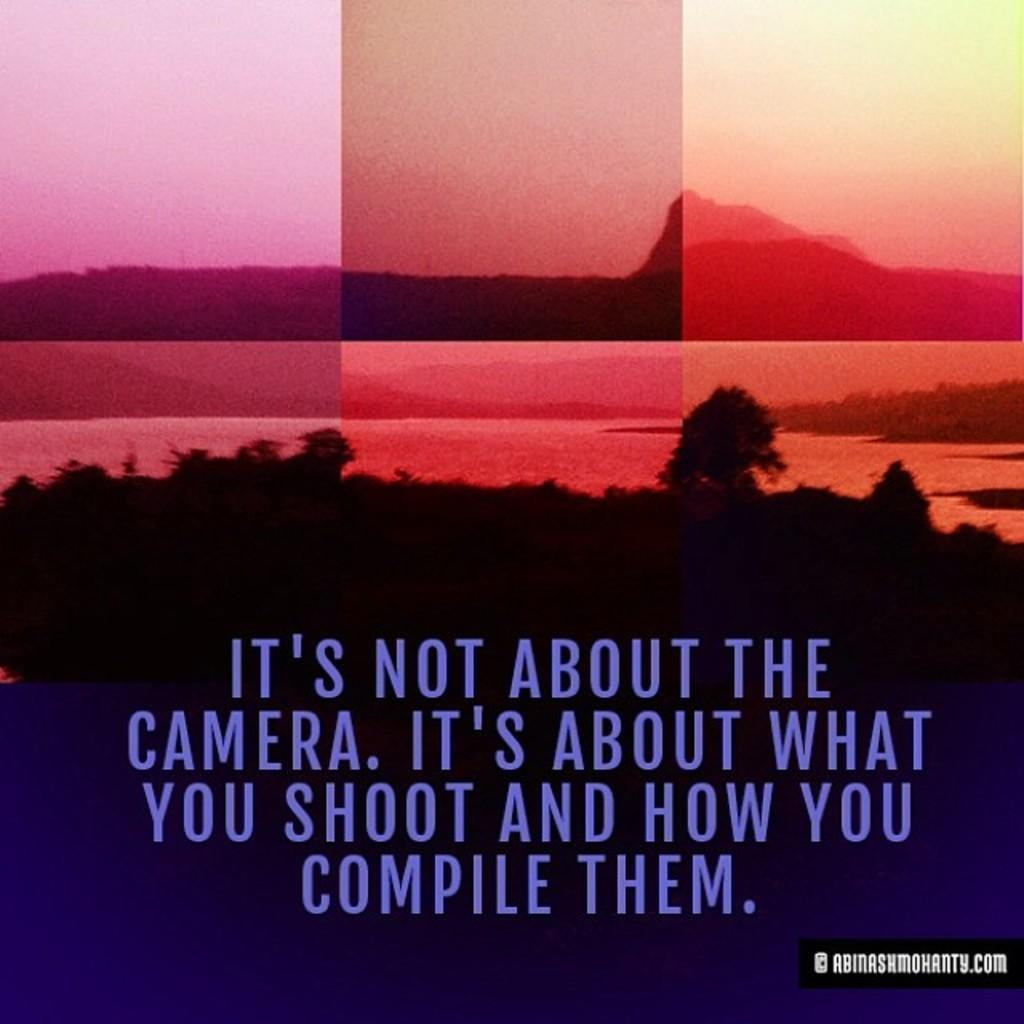<image>
Offer a succinct explanation of the picture presented. So the person writing this explains about photography and how it is not about the camera. 